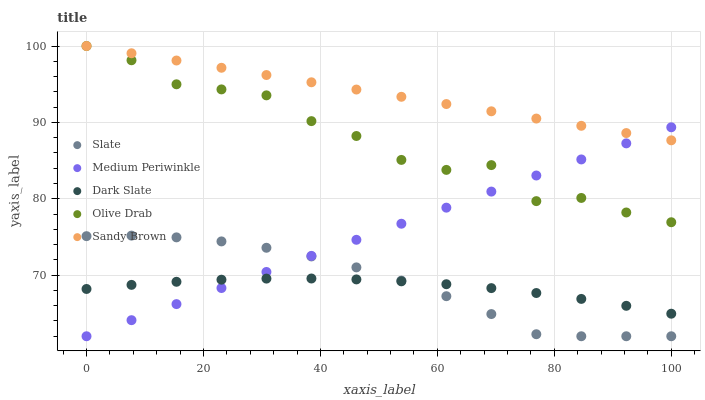Does Dark Slate have the minimum area under the curve?
Answer yes or no. Yes. Does Sandy Brown have the maximum area under the curve?
Answer yes or no. Yes. Does Slate have the minimum area under the curve?
Answer yes or no. No. Does Slate have the maximum area under the curve?
Answer yes or no. No. Is Sandy Brown the smoothest?
Answer yes or no. Yes. Is Olive Drab the roughest?
Answer yes or no. Yes. Is Slate the smoothest?
Answer yes or no. No. Is Slate the roughest?
Answer yes or no. No. Does Slate have the lowest value?
Answer yes or no. Yes. Does Sandy Brown have the lowest value?
Answer yes or no. No. Does Olive Drab have the highest value?
Answer yes or no. Yes. Does Slate have the highest value?
Answer yes or no. No. Is Dark Slate less than Sandy Brown?
Answer yes or no. Yes. Is Sandy Brown greater than Slate?
Answer yes or no. Yes. Does Dark Slate intersect Slate?
Answer yes or no. Yes. Is Dark Slate less than Slate?
Answer yes or no. No. Is Dark Slate greater than Slate?
Answer yes or no. No. Does Dark Slate intersect Sandy Brown?
Answer yes or no. No. 